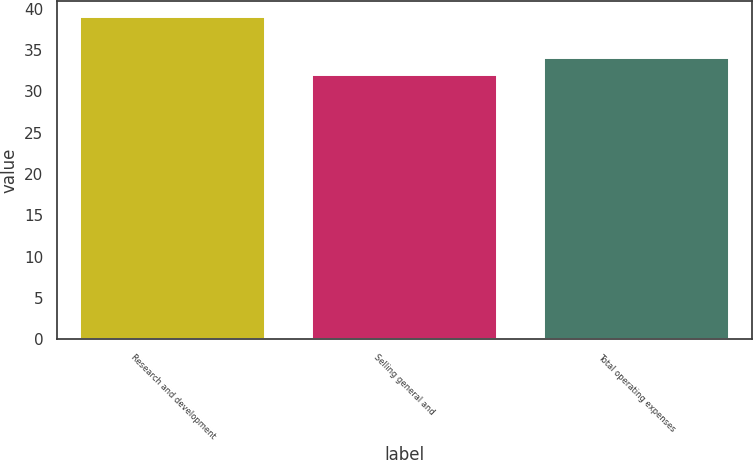<chart> <loc_0><loc_0><loc_500><loc_500><bar_chart><fcel>Research and development<fcel>Selling general and<fcel>Total operating expenses<nl><fcel>39<fcel>32<fcel>34<nl></chart> 